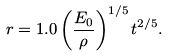<formula> <loc_0><loc_0><loc_500><loc_500>r = 1 . 0 \left ( \frac { E _ { 0 } } { \rho } \right ) ^ { 1 / 5 } t ^ { 2 / 5 } .</formula> 